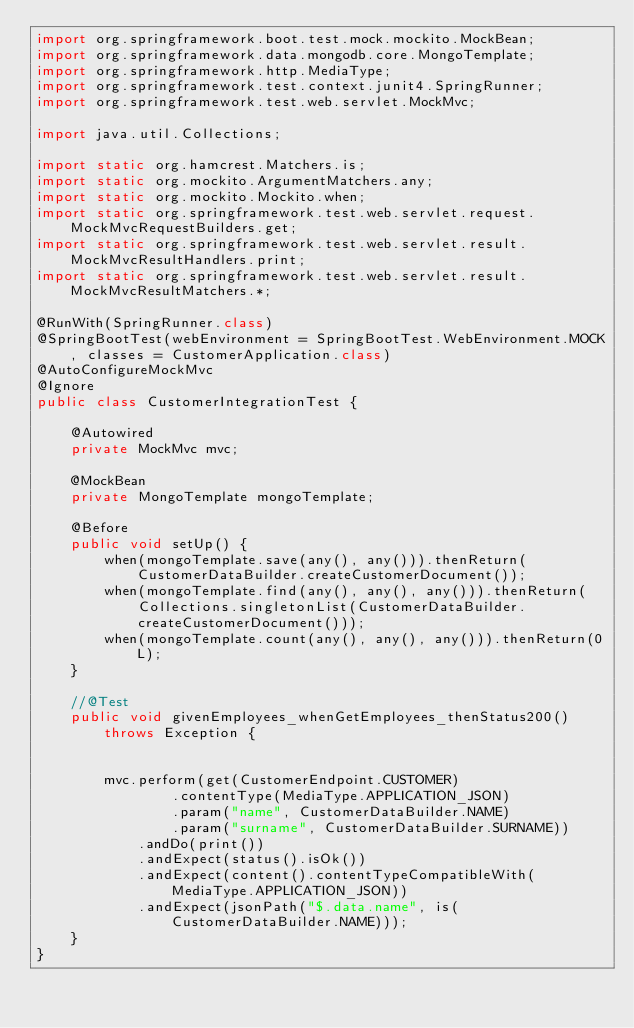Convert code to text. <code><loc_0><loc_0><loc_500><loc_500><_Java_>import org.springframework.boot.test.mock.mockito.MockBean;
import org.springframework.data.mongodb.core.MongoTemplate;
import org.springframework.http.MediaType;
import org.springframework.test.context.junit4.SpringRunner;
import org.springframework.test.web.servlet.MockMvc;

import java.util.Collections;

import static org.hamcrest.Matchers.is;
import static org.mockito.ArgumentMatchers.any;
import static org.mockito.Mockito.when;
import static org.springframework.test.web.servlet.request.MockMvcRequestBuilders.get;
import static org.springframework.test.web.servlet.result.MockMvcResultHandlers.print;
import static org.springframework.test.web.servlet.result.MockMvcResultMatchers.*;

@RunWith(SpringRunner.class)
@SpringBootTest(webEnvironment = SpringBootTest.WebEnvironment.MOCK, classes = CustomerApplication.class)
@AutoConfigureMockMvc
@Ignore
public class CustomerIntegrationTest {

    @Autowired
    private MockMvc mvc;

    @MockBean
    private MongoTemplate mongoTemplate;

    @Before
    public void setUp() {
        when(mongoTemplate.save(any(), any())).thenReturn(CustomerDataBuilder.createCustomerDocument());
        when(mongoTemplate.find(any(), any(), any())).thenReturn(Collections.singletonList(CustomerDataBuilder.createCustomerDocument()));
        when(mongoTemplate.count(any(), any(), any())).thenReturn(0L);
    }

    //@Test
    public void givenEmployees_whenGetEmployees_thenStatus200()
        throws Exception {


        mvc.perform(get(CustomerEndpoint.CUSTOMER)
                .contentType(MediaType.APPLICATION_JSON)
                .param("name", CustomerDataBuilder.NAME)
                .param("surname", CustomerDataBuilder.SURNAME))
            .andDo(print())
            .andExpect(status().isOk())
            .andExpect(content().contentTypeCompatibleWith(MediaType.APPLICATION_JSON))
            .andExpect(jsonPath("$.data.name", is(CustomerDataBuilder.NAME)));
    }
}
</code> 